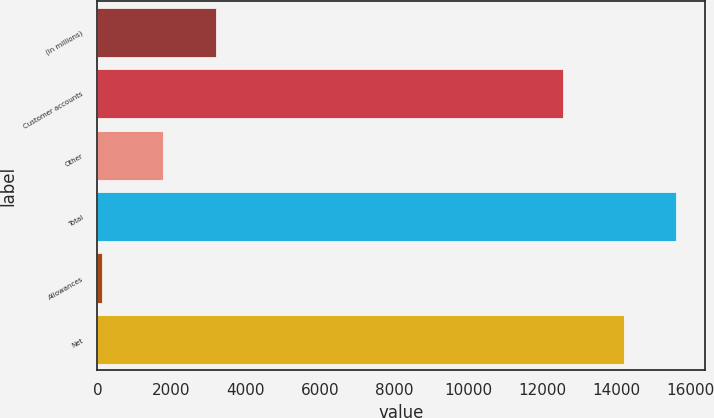Convert chart. <chart><loc_0><loc_0><loc_500><loc_500><bar_chart><fcel>(In millions)<fcel>Customer accounts<fcel>Other<fcel>Total<fcel>Allowances<fcel>Net<nl><fcel>3199.3<fcel>12543<fcel>1780<fcel>15612.3<fcel>130<fcel>14193<nl></chart> 